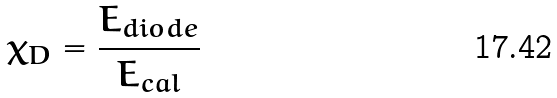<formula> <loc_0><loc_0><loc_500><loc_500>\chi _ { D } = \frac { E _ { d i o d e } } { E _ { c a l } }</formula> 